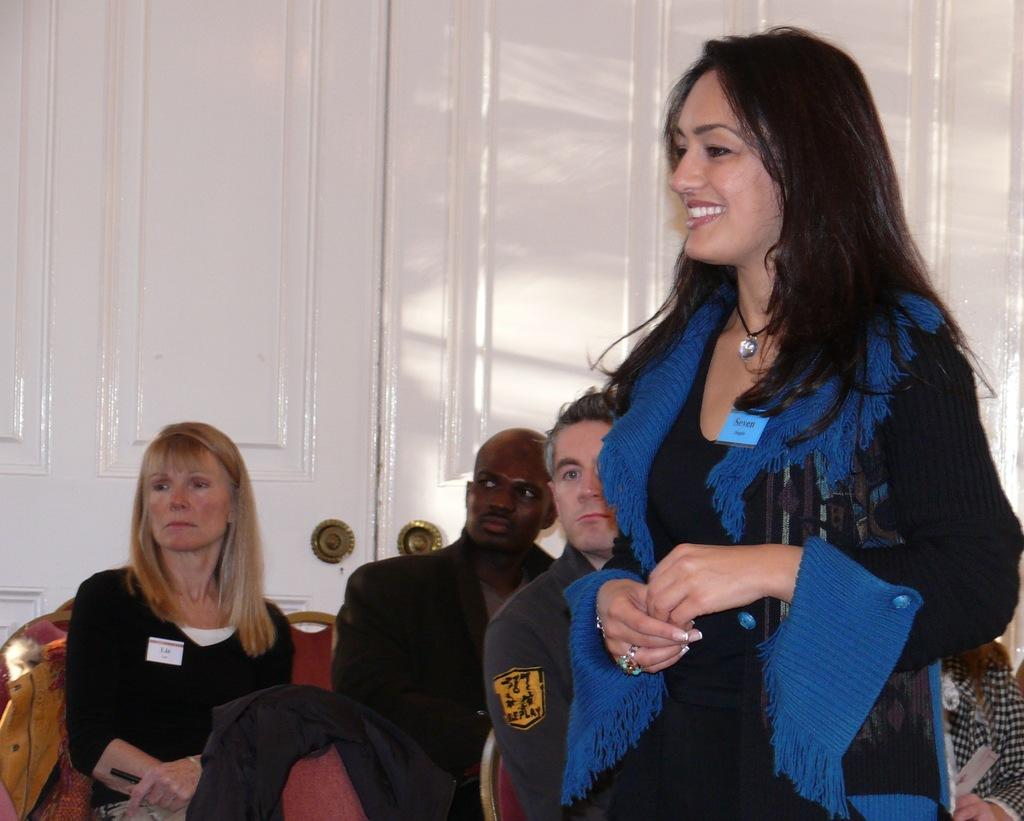What are the people in the image doing? The people in the image are sitting. What is the woman in the image doing? The woman is standing in the image. What is the expression on the woman's face? The woman is smiling. What can be seen in the background of the image? There is a white color door in the background of the image. How many nuts are being cracked by the rabbits in the image? There are no rabbits or nuts present in the image. What type of oil is being used by the people in the image? There is no oil mentioned or visible in the image. 